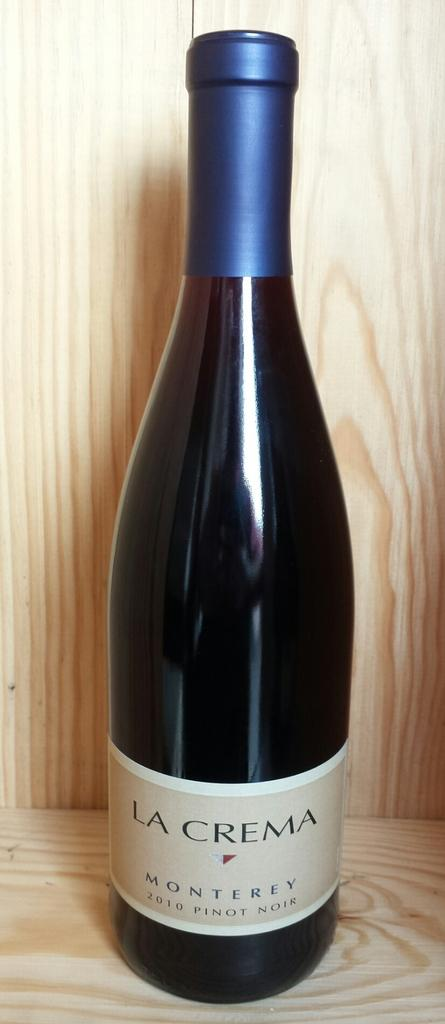<image>
Provide a brief description of the given image. A bottle of alcohol which has La Crema on the label. 